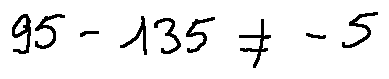Convert formula to latex. <formula><loc_0><loc_0><loc_500><loc_500>9 5 - 1 3 5 \neq - 5</formula> 